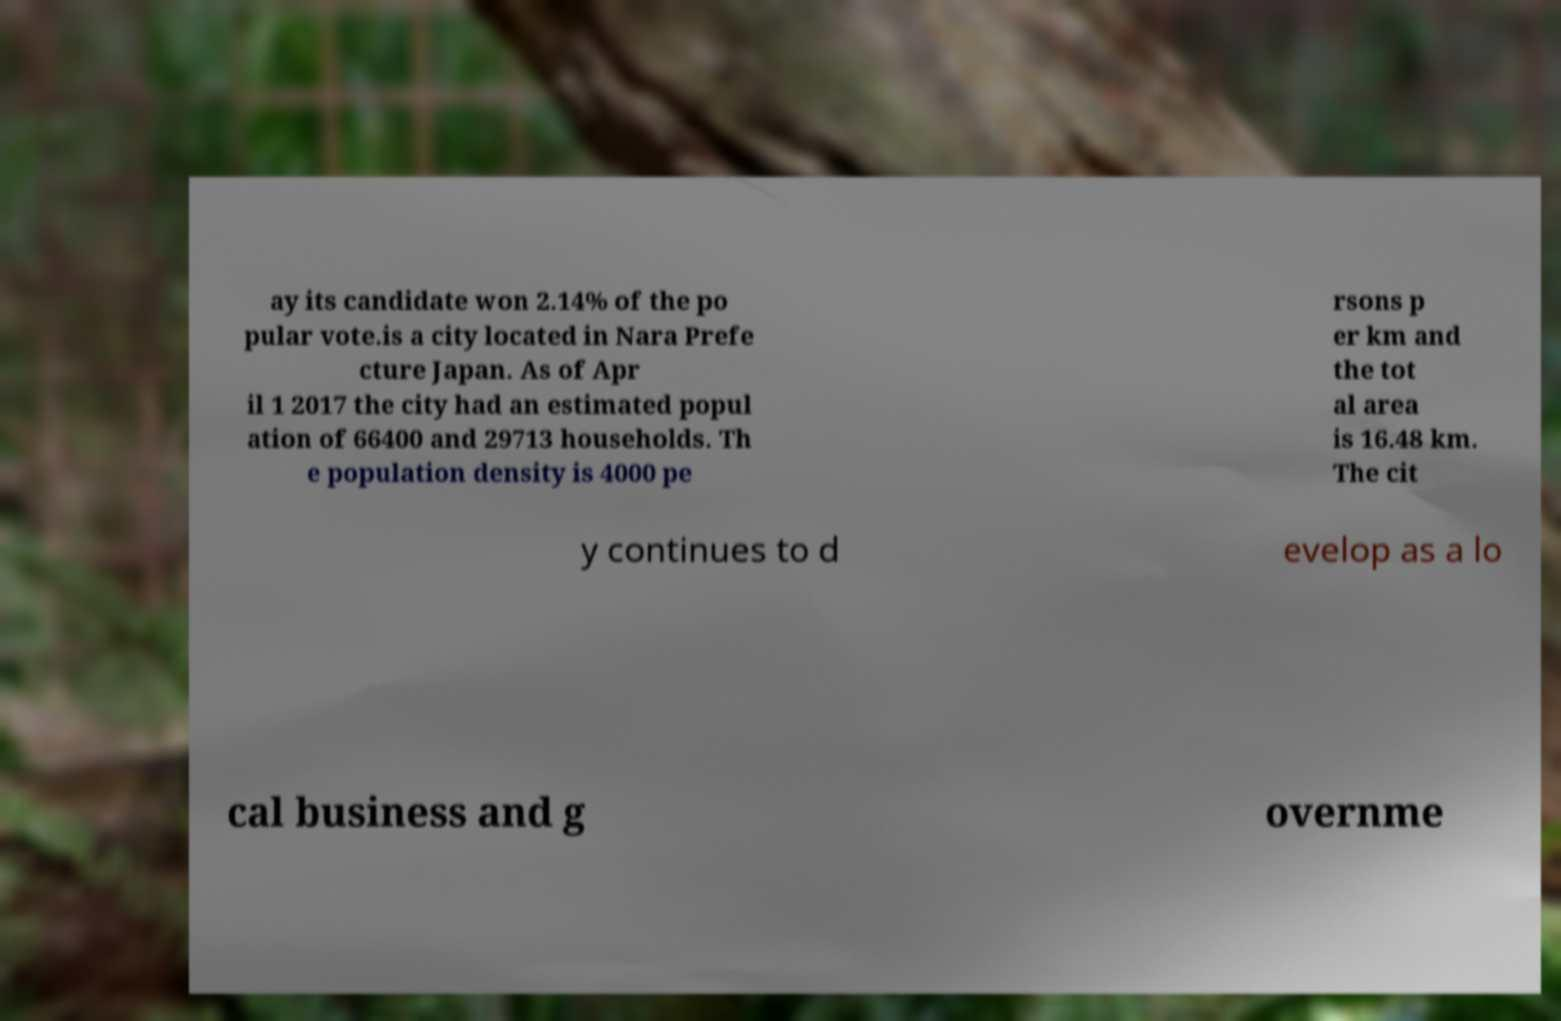For documentation purposes, I need the text within this image transcribed. Could you provide that? ay its candidate won 2.14% of the po pular vote.is a city located in Nara Prefe cture Japan. As of Apr il 1 2017 the city had an estimated popul ation of 66400 and 29713 households. Th e population density is 4000 pe rsons p er km and the tot al area is 16.48 km. The cit y continues to d evelop as a lo cal business and g overnme 